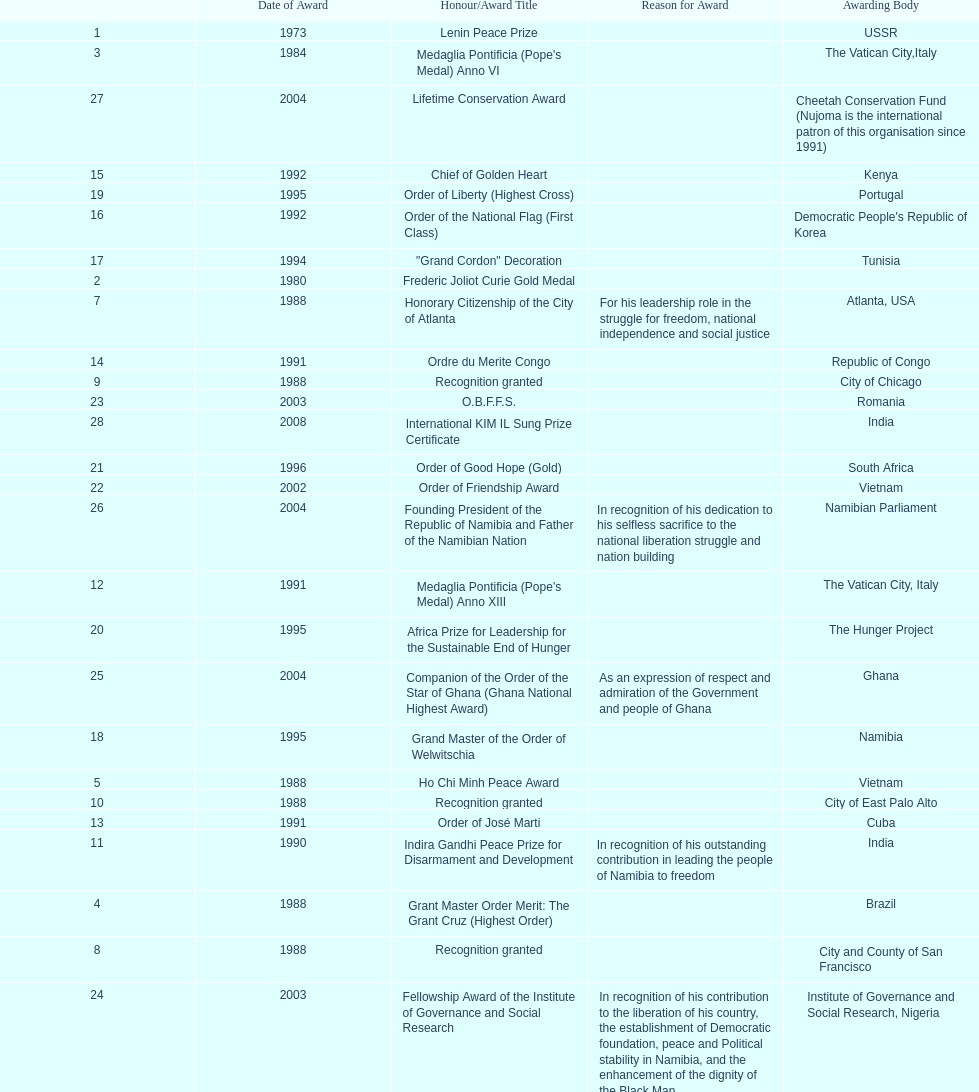The number of times "recognition granted" was the received award? 3. 